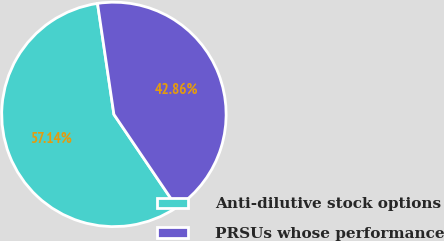Convert chart. <chart><loc_0><loc_0><loc_500><loc_500><pie_chart><fcel>Anti-dilutive stock options<fcel>PRSUs whose performance<nl><fcel>57.14%<fcel>42.86%<nl></chart> 